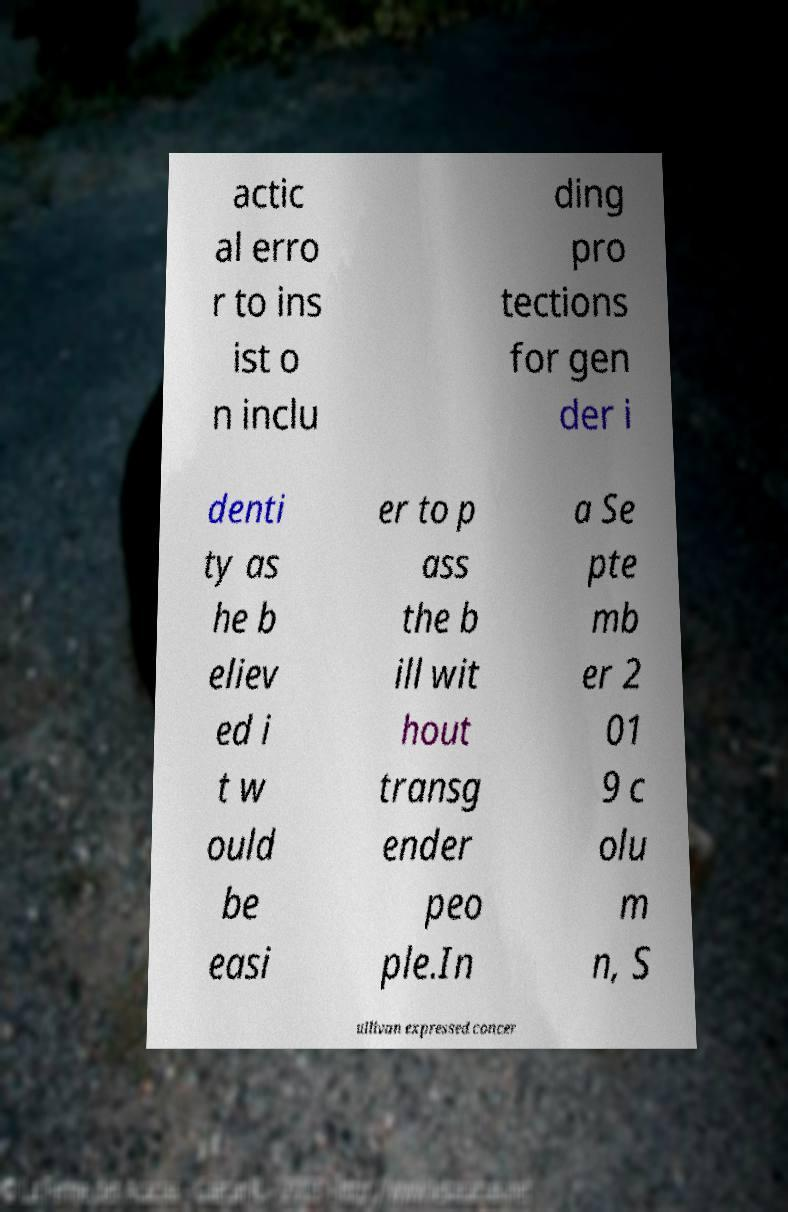Can you read and provide the text displayed in the image?This photo seems to have some interesting text. Can you extract and type it out for me? actic al erro r to ins ist o n inclu ding pro tections for gen der i denti ty as he b eliev ed i t w ould be easi er to p ass the b ill wit hout transg ender peo ple.In a Se pte mb er 2 01 9 c olu m n, S ullivan expressed concer 